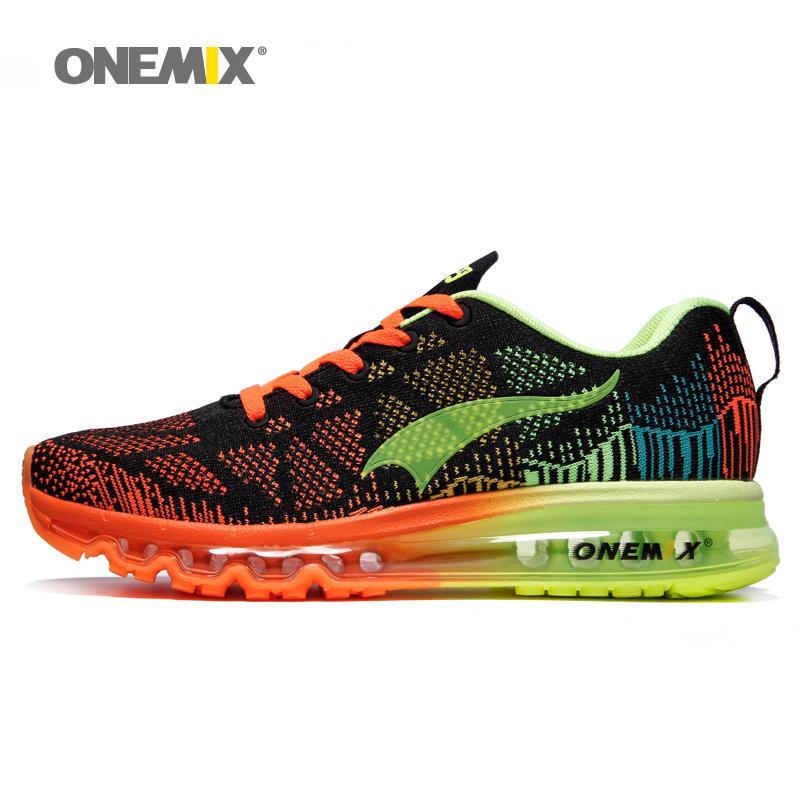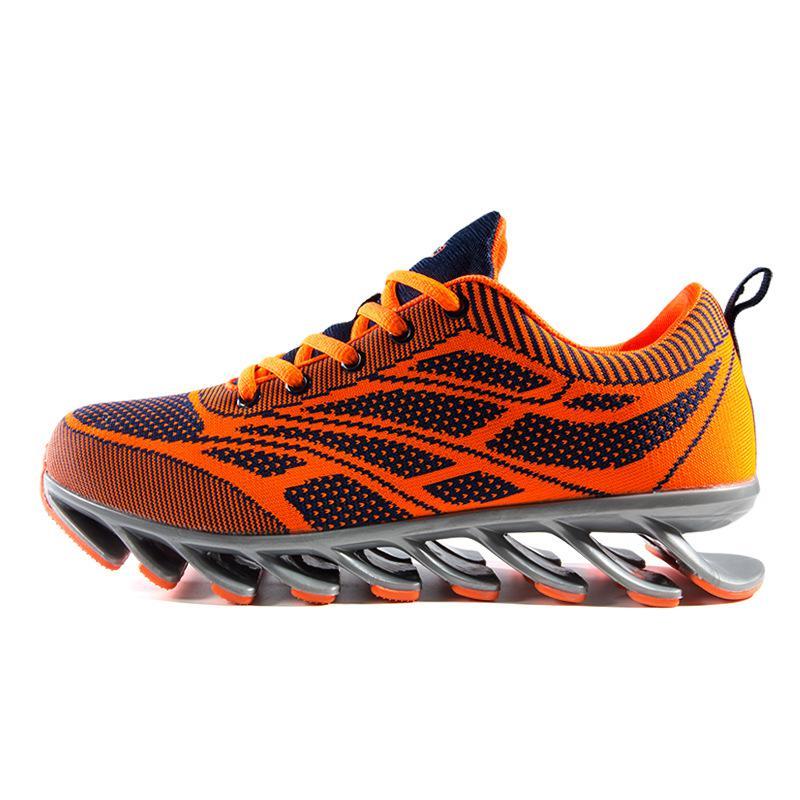The first image is the image on the left, the second image is the image on the right. Evaluate the accuracy of this statement regarding the images: "One image shows at least one black-laced shoe that is black with red and blue trim.". Is it true? Answer yes or no. No. The first image is the image on the left, the second image is the image on the right. Assess this claim about the two images: "A shoe facing left has a lime green ribbon shape on it in one image.". Correct or not? Answer yes or no. Yes. 